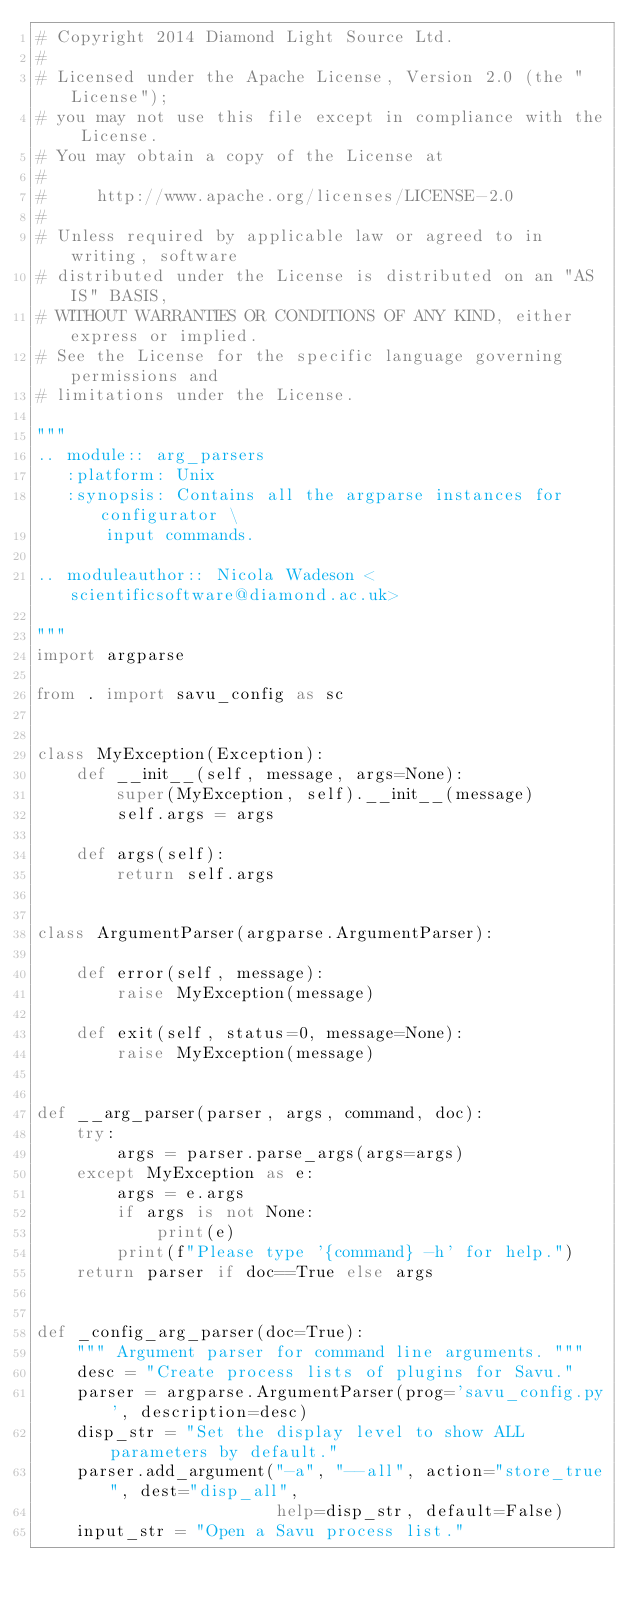Convert code to text. <code><loc_0><loc_0><loc_500><loc_500><_Python_># Copyright 2014 Diamond Light Source Ltd.
#
# Licensed under the Apache License, Version 2.0 (the "License");
# you may not use this file except in compliance with the License.
# You may obtain a copy of the License at
#
#     http://www.apache.org/licenses/LICENSE-2.0
#
# Unless required by applicable law or agreed to in writing, software
# distributed under the License is distributed on an "AS IS" BASIS,
# WITHOUT WARRANTIES OR CONDITIONS OF ANY KIND, either express or implied.
# See the License for the specific language governing permissions and
# limitations under the License.

"""
.. module:: arg_parsers
   :platform: Unix
   :synopsis: Contains all the argparse instances for configurator \
       input commands.

.. moduleauthor:: Nicola Wadeson <scientificsoftware@diamond.ac.uk>

"""
import argparse

from . import savu_config as sc


class MyException(Exception):
    def __init__(self, message, args=None):
        super(MyException, self).__init__(message)
        self.args = args

    def args(self):
        return self.args


class ArgumentParser(argparse.ArgumentParser):

    def error(self, message):
        raise MyException(message)

    def exit(self, status=0, message=None):
        raise MyException(message)


def __arg_parser(parser, args, command, doc):
    try:
        args = parser.parse_args(args=args)
    except MyException as e:
        args = e.args
        if args is not None:
            print(e)
        print(f"Please type '{command} -h' for help.")
    return parser if doc==True else args


def _config_arg_parser(doc=True):
    """ Argument parser for command line arguments. """
    desc = "Create process lists of plugins for Savu."
    parser = argparse.ArgumentParser(prog='savu_config.py', description=desc)
    disp_str = "Set the display level to show ALL parameters by default."
    parser.add_argument("-a", "--all", action="store_true", dest="disp_all",
                        help=disp_str, default=False)
    input_str = "Open a Savu process list."</code> 